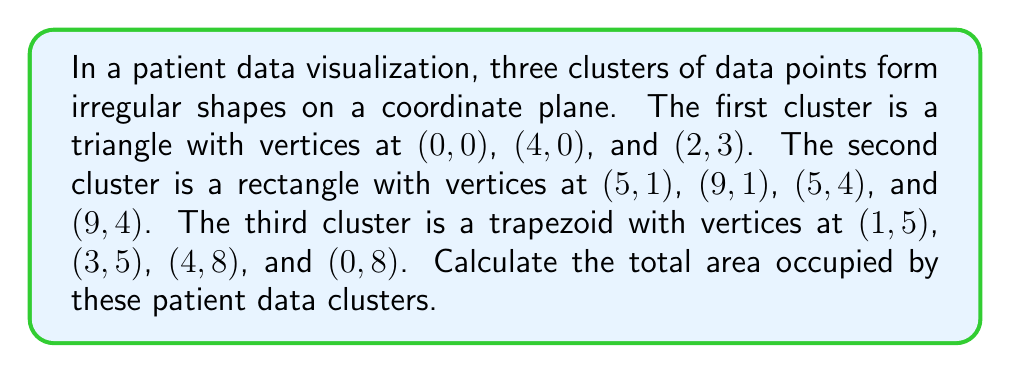Solve this math problem. Let's calculate the area of each cluster separately:

1. Triangle (Cluster 1):
   Area = $\frac{1}{2} \times base \times height$
   Base = 4, Height = 3
   $A_1 = \frac{1}{2} \times 4 \times 3 = 6$ square units

2. Rectangle (Cluster 2):
   Area = length $\times$ width
   Length = 9 - 5 = 4, Width = 4 - 1 = 3
   $A_2 = 4 \times 3 = 12$ square units

3. Trapezoid (Cluster 3):
   Area = $\frac{1}{2}(a+b)h$, where a and b are parallel sides and h is the height
   $a = 3 - 1 = 2$, $b = 4 - 0 = 4$, $h = 8 - 5 = 3$
   $A_3 = \frac{1}{2}(2+4) \times 3 = 9$ square units

Total area = $A_1 + A_2 + A_3 = 6 + 12 + 9 = 27$ square units

[asy]
unitsize(1cm);
draw((0,0)--(4,0)--(2,3)--cycle);
draw((5,1)--(9,1)--(9,4)--(5,4)--cycle);
draw((1,5)--(3,5)--(4,8)--(0,8)--cycle);
label("Cluster 1", (2,1));
label("Cluster 2", (7,2.5));
label("Cluster 3", (2,6.5));
[/asy]
Answer: 27 square units 